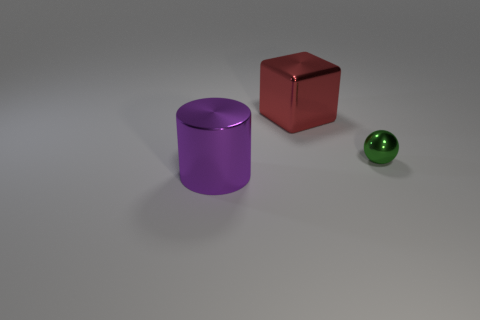If the sphere is a marble, what can you infer about the scale of the scene? Assuming the sphere is a marble, typically around 16mm in diameter, this scene could be quite small, with the objects representing miniature models rather than life-sized items. 